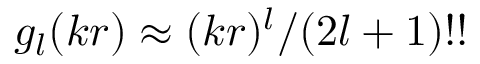<formula> <loc_0><loc_0><loc_500><loc_500>g _ { l } ( k r ) \approx ( k r ) ^ { l } / ( 2 l + 1 ) ! !</formula> 